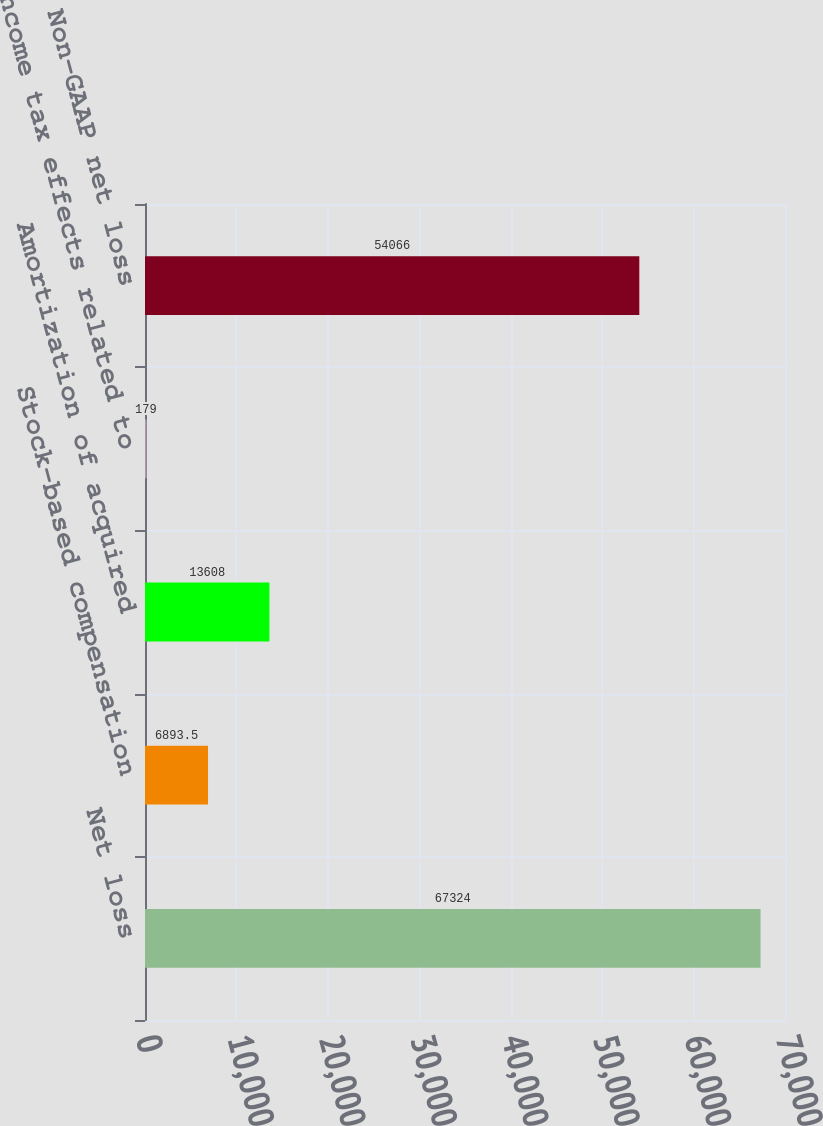<chart> <loc_0><loc_0><loc_500><loc_500><bar_chart><fcel>Net loss<fcel>Stock-based compensation<fcel>Amortization of acquired<fcel>Income tax effects related to<fcel>Non-GAAP net loss<nl><fcel>67324<fcel>6893.5<fcel>13608<fcel>179<fcel>54066<nl></chart> 